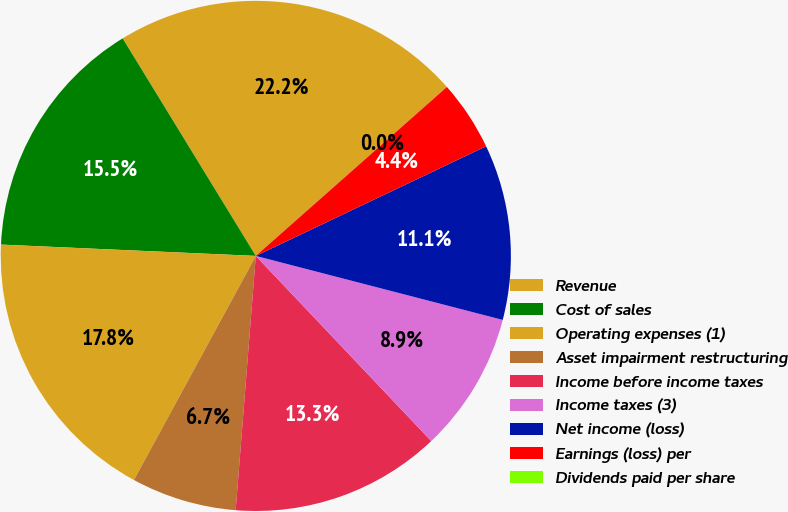Convert chart. <chart><loc_0><loc_0><loc_500><loc_500><pie_chart><fcel>Revenue<fcel>Cost of sales<fcel>Operating expenses (1)<fcel>Asset impairment restructuring<fcel>Income before income taxes<fcel>Income taxes (3)<fcel>Net income (loss)<fcel>Earnings (loss) per<fcel>Dividends paid per share<nl><fcel>22.22%<fcel>15.55%<fcel>17.78%<fcel>6.67%<fcel>13.33%<fcel>8.89%<fcel>11.11%<fcel>4.45%<fcel>0.0%<nl></chart> 